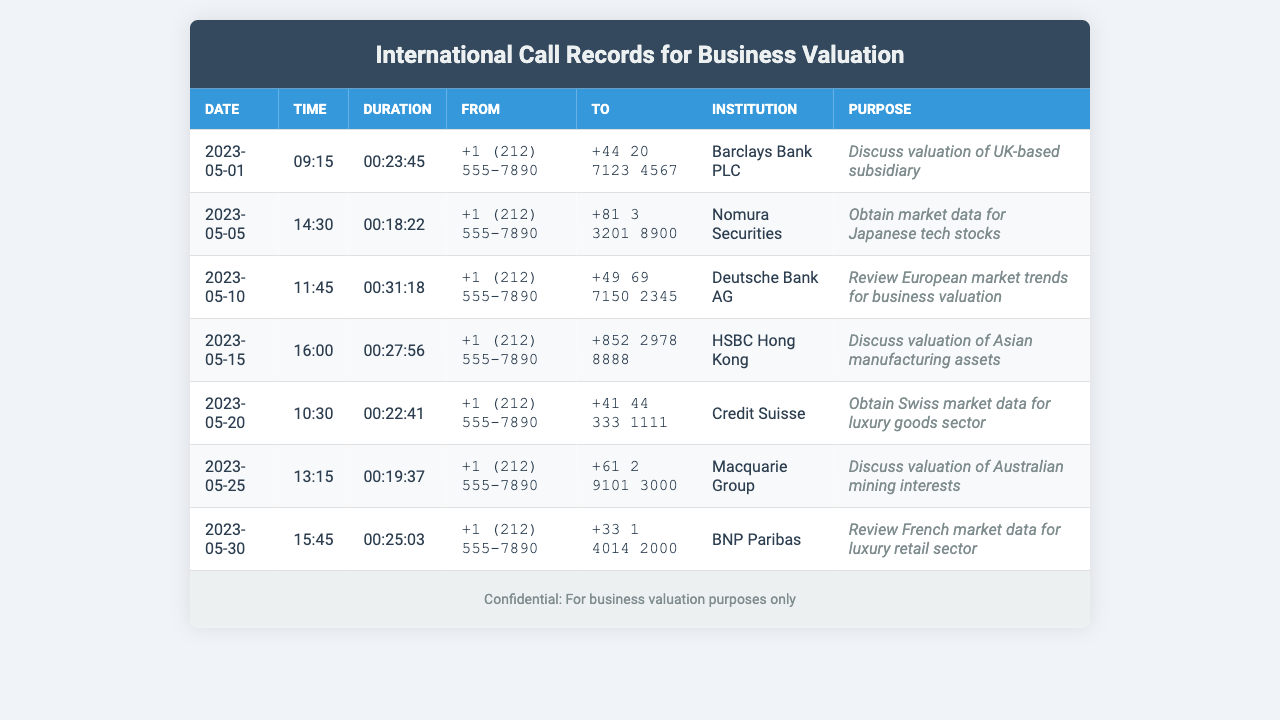What is the date of the call to Barclays Bank? The date of the call to Barclays Bank is indicated in the document as May 1, 2023.
Answer: 2023-05-01 What is the duration of the call to Deutsche Bank? The call duration to Deutsche Bank on May 10, 2023, was listed in the document as 00:31:18.
Answer: 00:31:18 Which institution was contacted on May 20? The document lists the call made on May 20, 2023, as being to Credit Suisse.
Answer: Credit Suisse What was the purpose of the call to Nomura Securities? The reason for the call to Nomura Securities on May 5, 2023, was to obtain market data for Japanese tech stocks.
Answer: Obtain market data for Japanese tech stocks Which phone number corresponds to HSBC Hong Kong? The document shows that the phone number for HSBC Hong Kong is +852 2978 8888.
Answer: +852 2978 8888 How many calls were made to institutions in May 2023? A count of the calls listed shows there were a total of seven calls made to different institutions in May 2023.
Answer: 7 What was the primary focus of the call to BNP Paribas? The document states that the focus of the call to BNP Paribas on May 30, 2023, was to review French market data for luxury retail sector.
Answer: Review French market data for luxury retail sector Which country was the recipient of the call on May 25? The call on May 25, 2023, was made to an institution in Australia, indicated by the phone number format and the institution being Macquarie Group.
Answer: Australia 